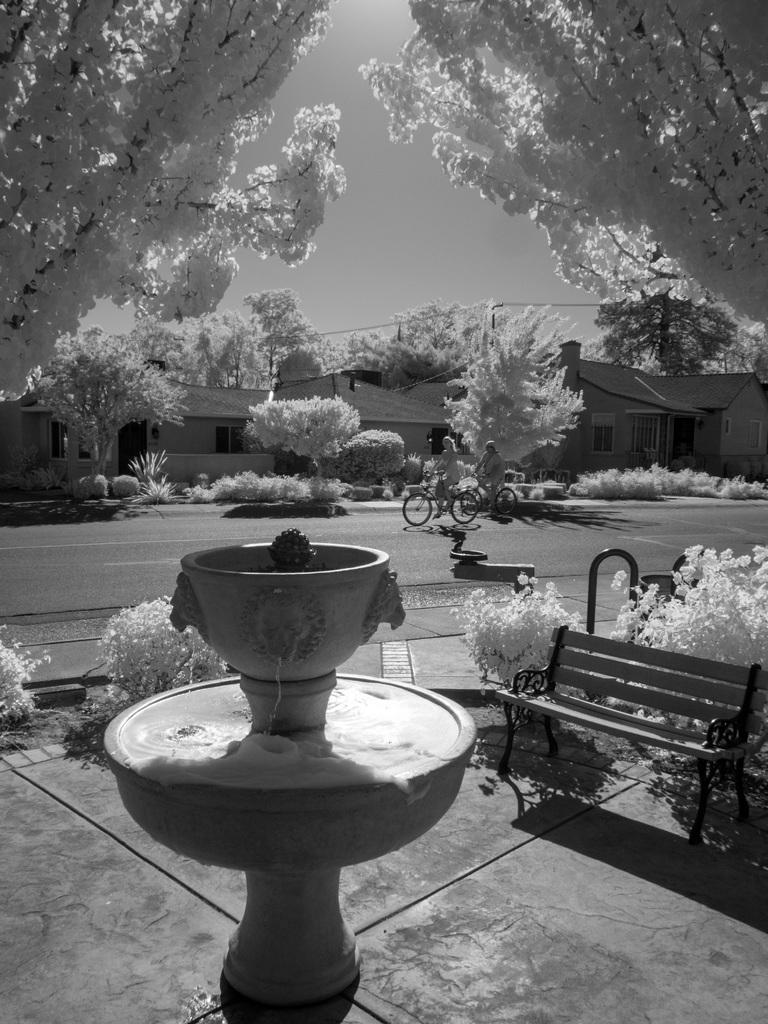What is the main object in the image? There is a pot in the image. What is growing in the pot? There is a plant in the image. What type of seating is visible in the image? There is a bench in the image. What can be seen in the background of the image? There is a bicycle, a building, the sky, and a tree visible in the background of the image. Where are the scissors being used to cut the tree in the image? There are no scissors or tree-cutting activity present in the image. What type of laborer is working on the bicycle in the background of the image? There is no laborer or bicycle-related work being done in the image. 